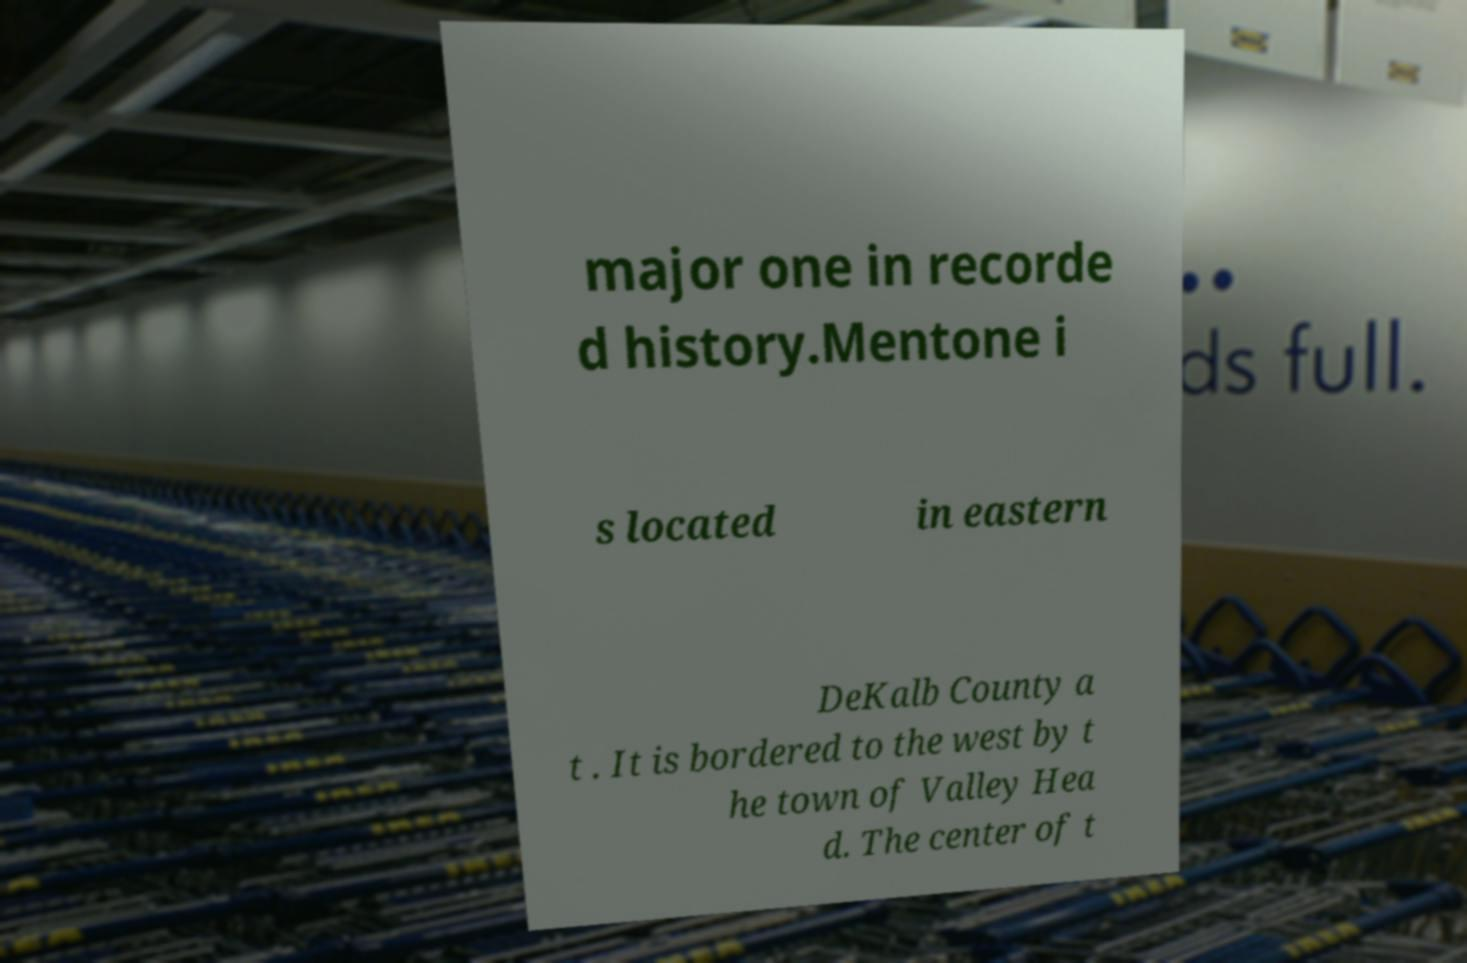There's text embedded in this image that I need extracted. Can you transcribe it verbatim? major one in recorde d history.Mentone i s located in eastern DeKalb County a t . It is bordered to the west by t he town of Valley Hea d. The center of t 